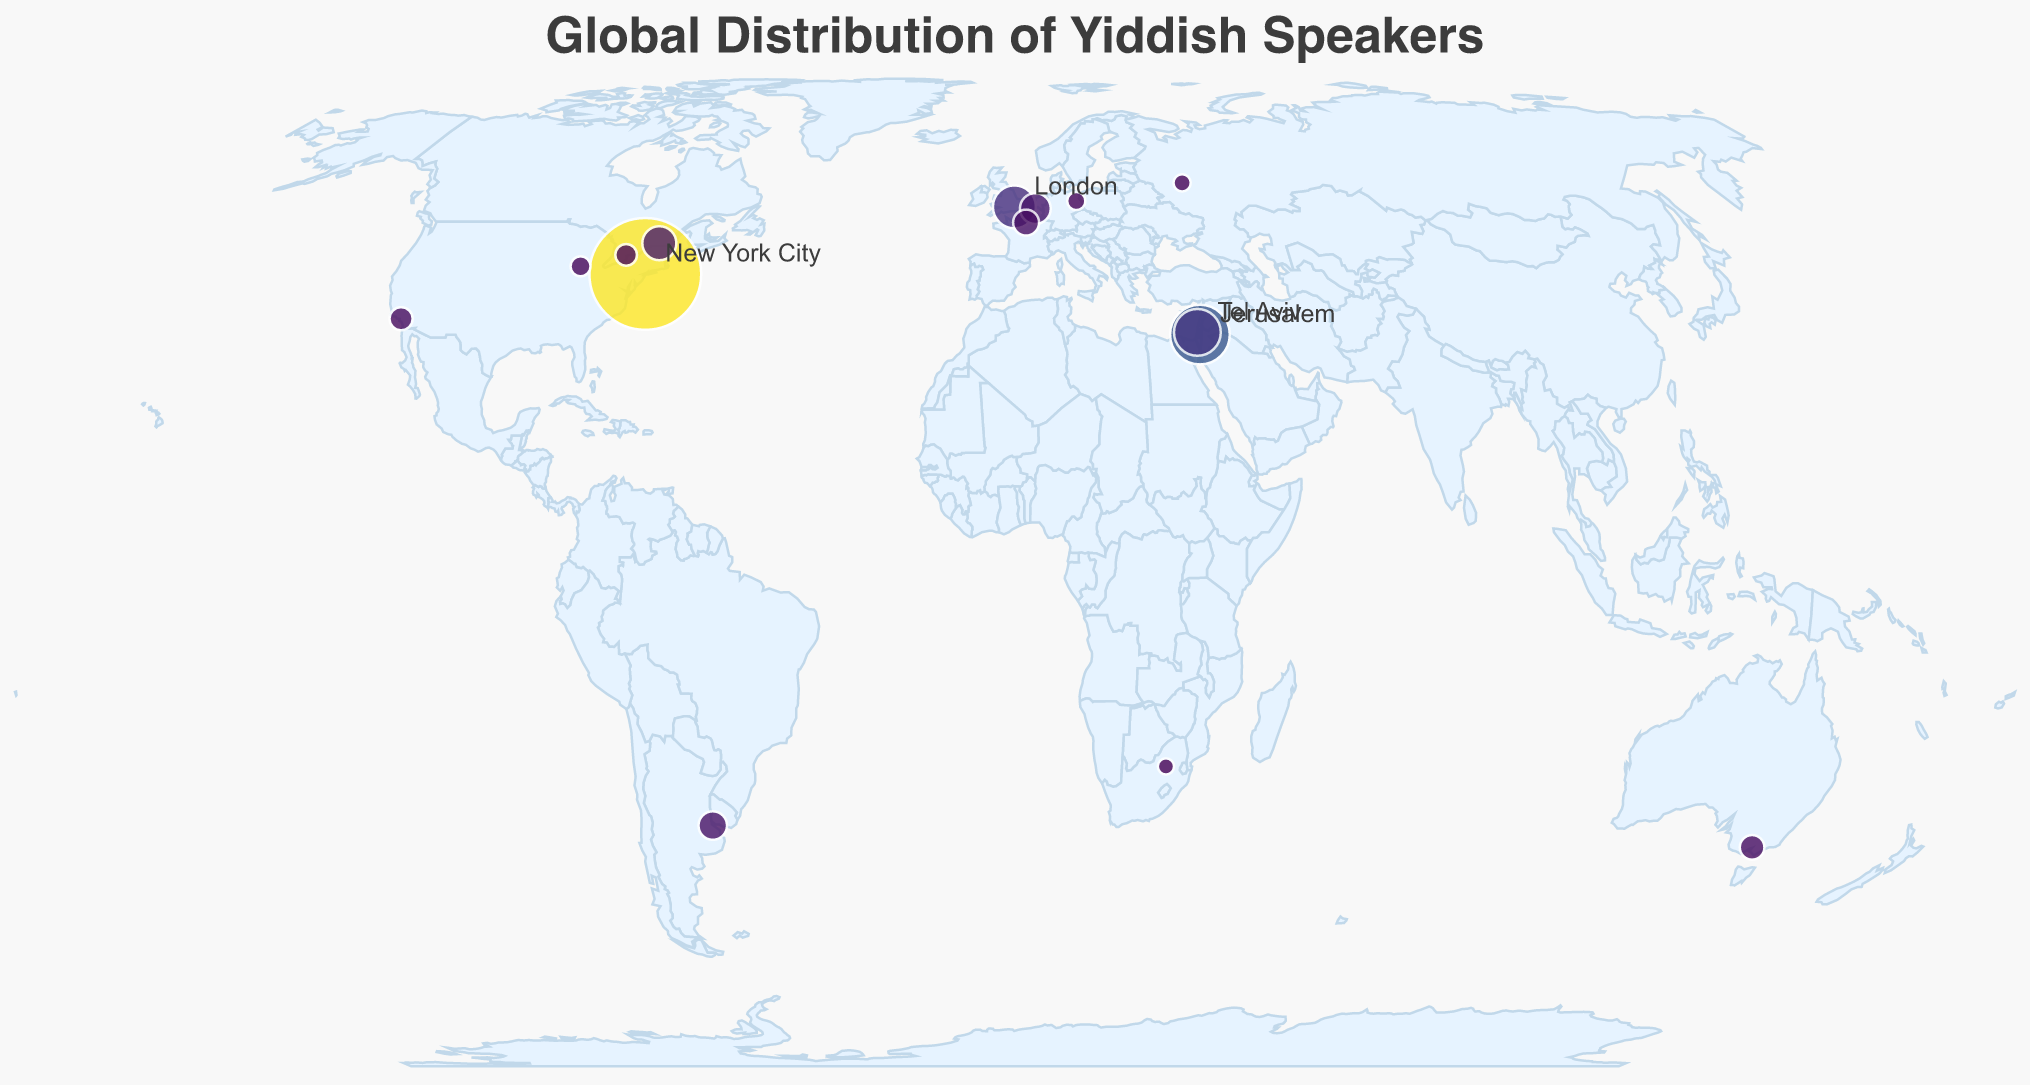What is the title of the figure? The title of the figure is displayed prominently at the top and often summarizes the content. In this case, it says "Global Distribution of Yiddish Speakers."
Answer: Global Distribution of Yiddish Speakers Which city has the highest number of Yiddish speakers? By examining the size and color of the circles, we can see that New York City has the largest circle and the most intense color, indicating the highest number.
Answer: New York City How many Yiddish speakers are there in Antwerp? Hovering over the circle in Antwerp displays a tooltip that explicitly shows the number of Yiddish speakers.
Answer: 12,000 What’s the total number of Yiddish speakers in Israel? Summing up the Yiddish speakers in Jerusalem (50,000) and Tel Aviv (30,000) gives the total for Israel. So, 50,000 + 30,000 = 80,000 Yiddish speakers in Israel.
Answer: 80,000 Which city has more Yiddish speakers, Los Angeles or Chicago? From the map, the circle representing Los Angeles is larger and a more intense color compared to Chicago. Los Angeles has 6,000 Yiddish speakers while Chicago has 4,000.
Answer: Los Angeles What is the latitude and longitude of Buenos Aires? Hovering over the circle in Buenos Aires will display a tooltip that shows the exact latitude and longitude.
Answer: -34.6037, -58.3816 Which city has the smallest number of Yiddish speakers, and how many are there? By examining the size and color of the circles, we can identify that Johannesburg has the smallest circle, indicating the smallest number. Hovering over it confirms the number.
Answer: Johannesburg, 2,000 What is the average number of Yiddish speakers among the cities listed on the map? Summing up all the Yiddish speakers across all cities and then dividing by the number of cities gives the average. (180,000 + 50,000 + 30,000 + 25,000 + 15,000 + 12,000 + 10,000 + 8,000 + 7,000 + 6,000 + 5,000 + 4,000 + 3,000 + 2,500 + 2,000) / 15 = 23,633.33.
Answer: 23,633.33 Which two cities have an equal number of Yiddish speakers? By comparing the number of Yiddish speakers, we find that there are no cities with an equal number of Yiddish speakers based on the data provided.
Answer: None How many cities have more than 10,000 Yiddish speakers listed? The cities with more than 10,000 Yiddish speakers are New York City, Jerusalem, Tel Aviv, London, and Montreal. That's 5 cities in total.
Answer: 5 